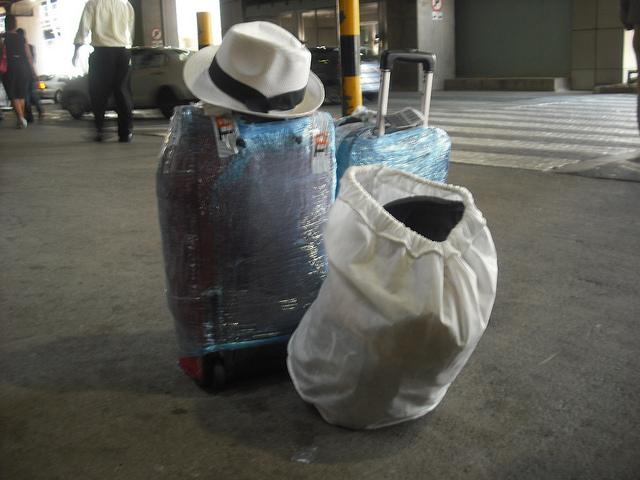Is there a handle on the suitcase?
Short answer required. Yes. What is the man in the back wearing?
Answer briefly. Clothes. Does the hat make the bag look sexy?
Keep it brief. No. 